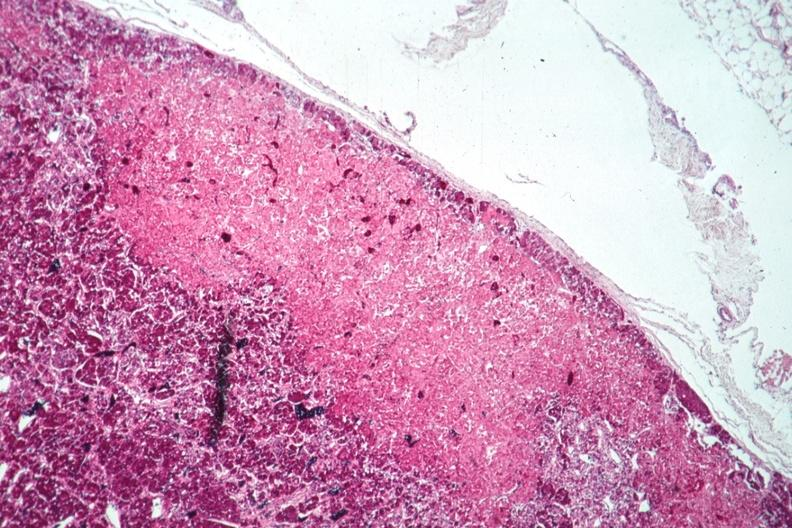s endocrine present?
Answer the question using a single word or phrase. Yes 